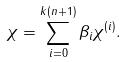Convert formula to latex. <formula><loc_0><loc_0><loc_500><loc_500>\chi = \sum _ { i = 0 } ^ { k ( n + 1 ) } \beta _ { i } \chi ^ { ( i ) } .</formula> 